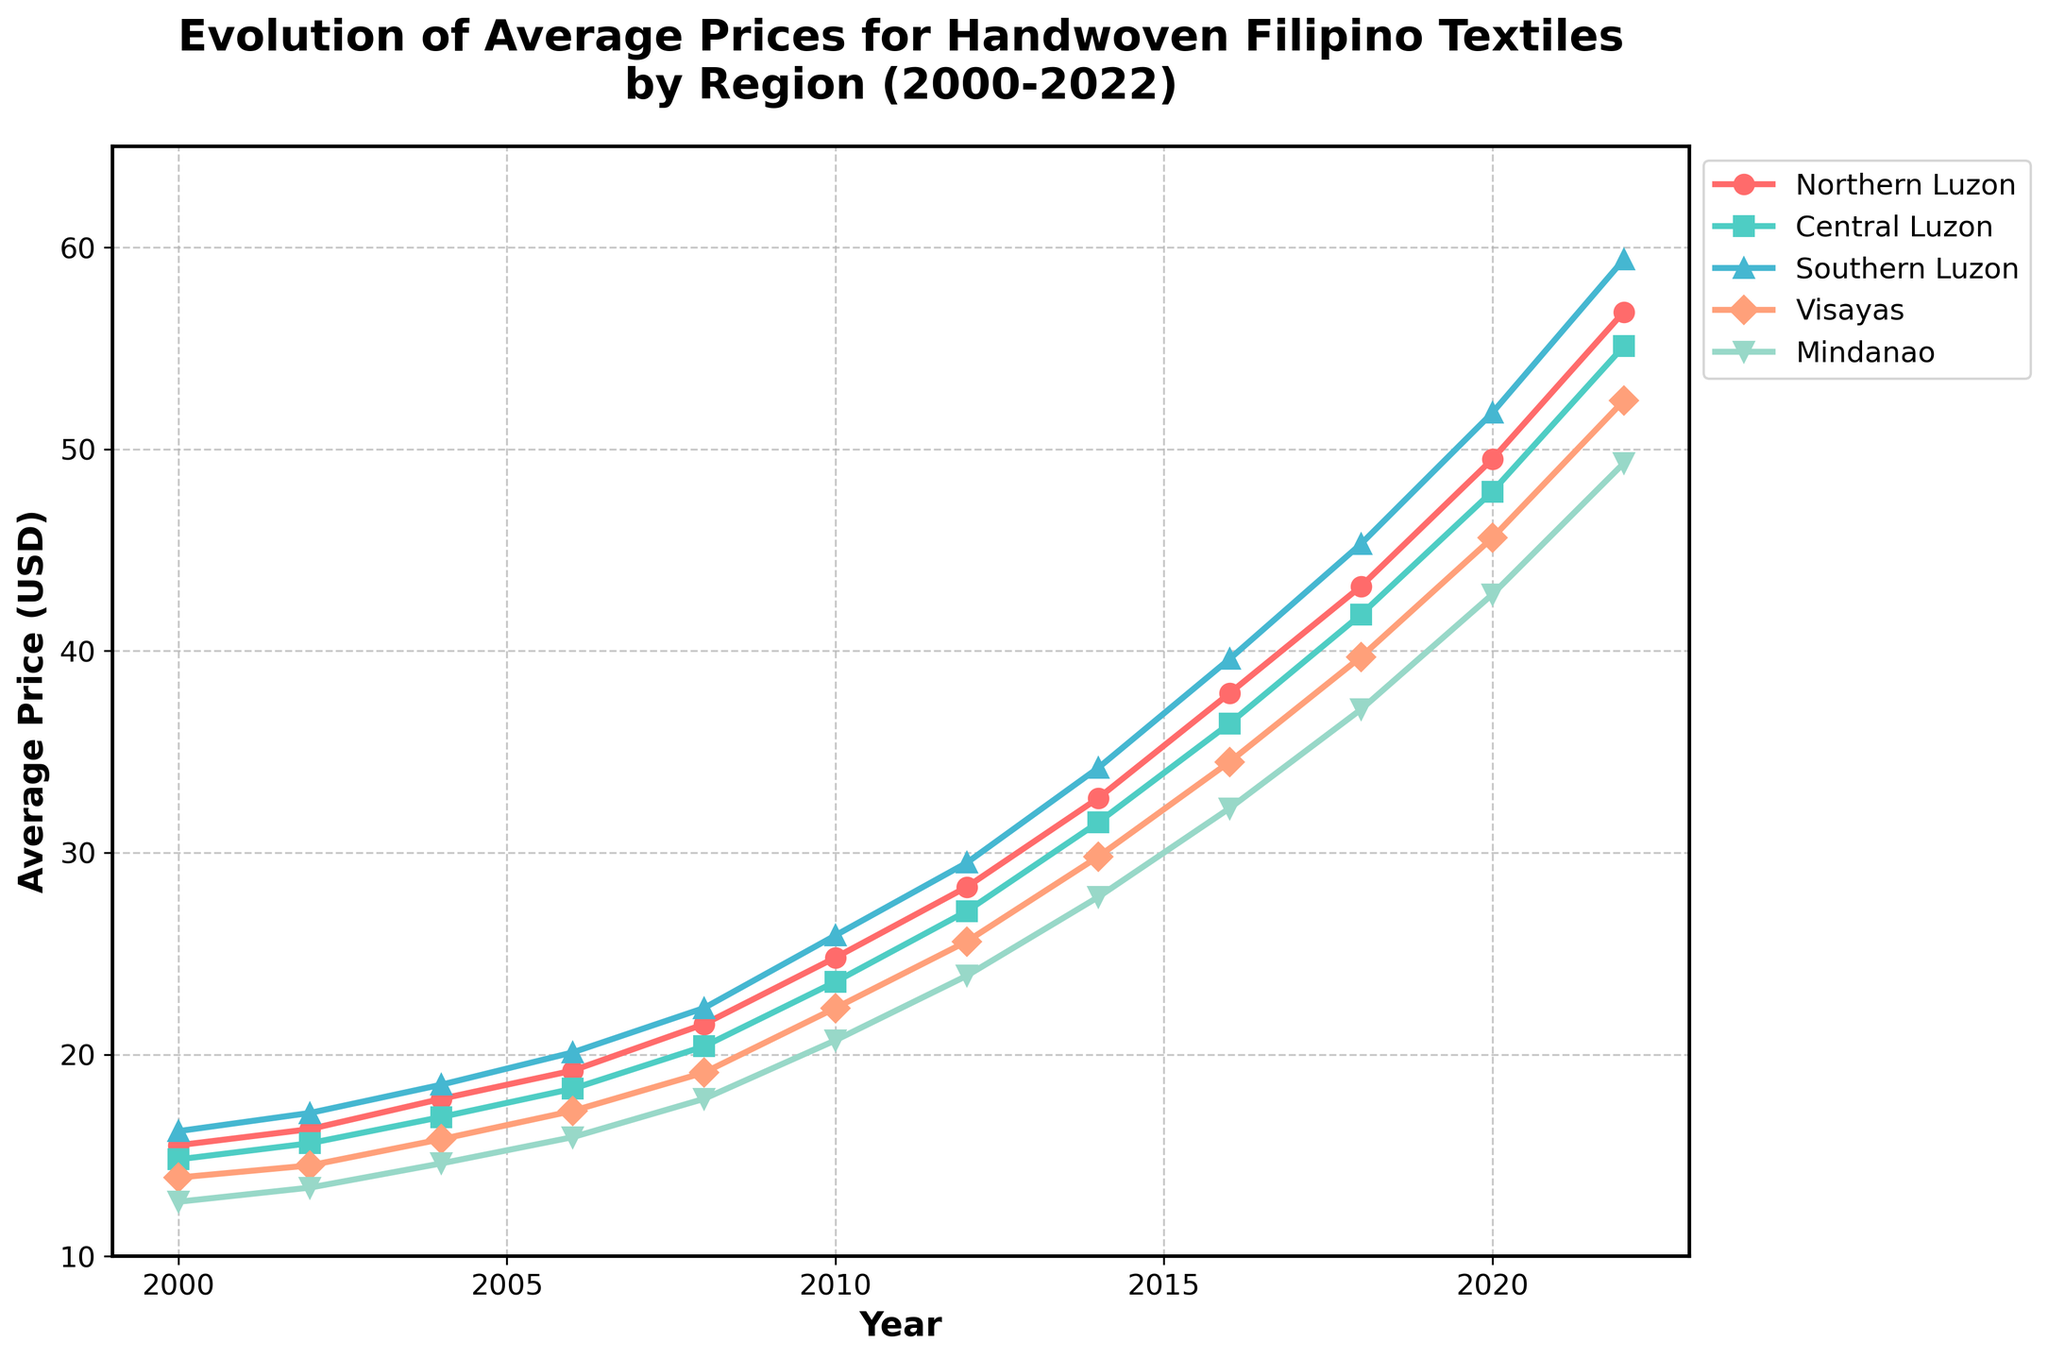What's the average price of handwoven textiles in Southern Luzon in 2000 and 2022? To find the answer, look at the 'Southern Luzon' segment in 2000 and 2022, which are 16.20 USD and 59.40 USD. Calculate the average of these two values: (16.20 + 59.40) / 2 = 37.80.
Answer: 37.80 Which region had the highest average price for handwoven textiles in 2018? Look at the plot for all regions in 2018 and compare their heights. Southern Luzon has the highest average price with 45.30 USD.
Answer: Southern Luzon By how much did the average price for handwoven textiles in Mindanao increase from 2000 to 2022? Look at Mindanao's prices for 2000 and 2022, which are 12.70 USD and 49.30 USD respectively. Subtract the price in 2000 from the price in 2022: 49.30 - 12.70 = 36.60.
Answer: 36.60 Which region had a steady price increase over the years, with no decrease, and the steepest rise overall? Observe all regions' trends from 2000 to 2022. Southern Luzon shows a consistent increase with no dips, and has the steepest rise overall from 16.20 USD in 2000 to 59.40 USD in 2022.
Answer: Southern Luzon In which year did Central Luzon surpass the 20 USD mark? Trace Central Luzon's line and find the year when it first crosses 20 USD. This occurs in 2008 when the price reached 20.40 USD.
Answer: 2008 What's the difference in average prices for Northern Luzon and Visayas in 2020? Look at the values for Northern Luzon and Visayas in 2020, which are 49.50 USD and 45.60 USD respectively. Subtract Visayas' price from Northern Luzon's price: 49.50 - 45.60 = 3.90.
Answer: 3.90 Which years did all regions show a simultaneous increase in their average prices compared to the previous data point? Determine the years when all regions' lines rise compared to the previous year. These years are 2002, 2004, 2006, 2008, 2010, 2012, 2014, 2016, 2018, 2020, and 2022 (every year in the data provided shows an increase).
Answer: Every year from 2002 to 2022 How does the magnitude of price increase in Northern Luzon from 2000 to 2022 compare with that of Visayas? Calculate the increase for Northern Luzon: 56.80 - 15.50 = 41.30 USD and for Visayas: 52.40 - 13.90 = 38.50 USD. Compare these increases: 41.30 (Northern Luzon) is greater than 38.50 (Visayas).
Answer: Northern Luzon's increase is greater Which region had the smallest price increase in 2006? Compare the increases between 2004 and 2006 for each region: Northern Luzon (19.20 - 17.80 = 1.40), Central Luzon (18.30 - 16.90 = 1.40), Southern Luzon (20.10 - 18.50 = 1.60), Visayas (17.20 - 15.80 = 1.40), and Mindanao (15.90 - 14.60 = 1.30). Mindanao had the smallest increase.
Answer: Mindanao 